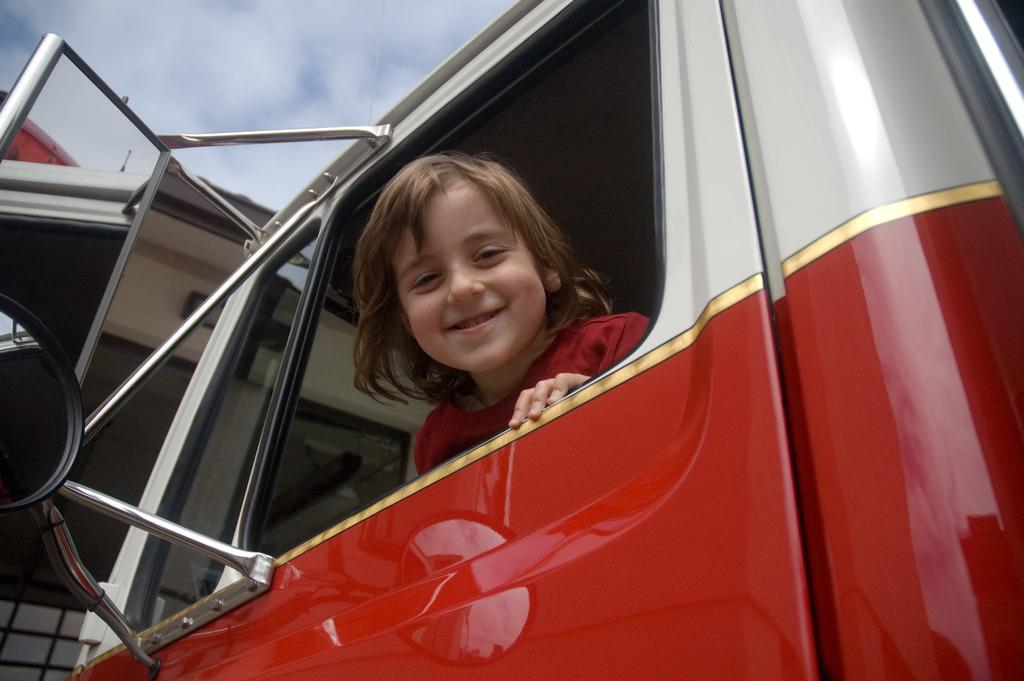What is the main subject of the image? The main subject of the image is a kid. What is the kid wearing in the image? The kid is wearing a red T-shirt. Where is the kid located in the image? The kid is sitting in a vehicle. What color is the vehicle in the image? The vehicle is red in color. How would you describe the weather in the image? The sky is cloudy in the image, suggesting a potentially overcast or cloudy day. What type of thread is being used to play music in the image? There is no thread or music present in the image; it features a kid sitting in a red vehicle with a cloudy sky in the background. 